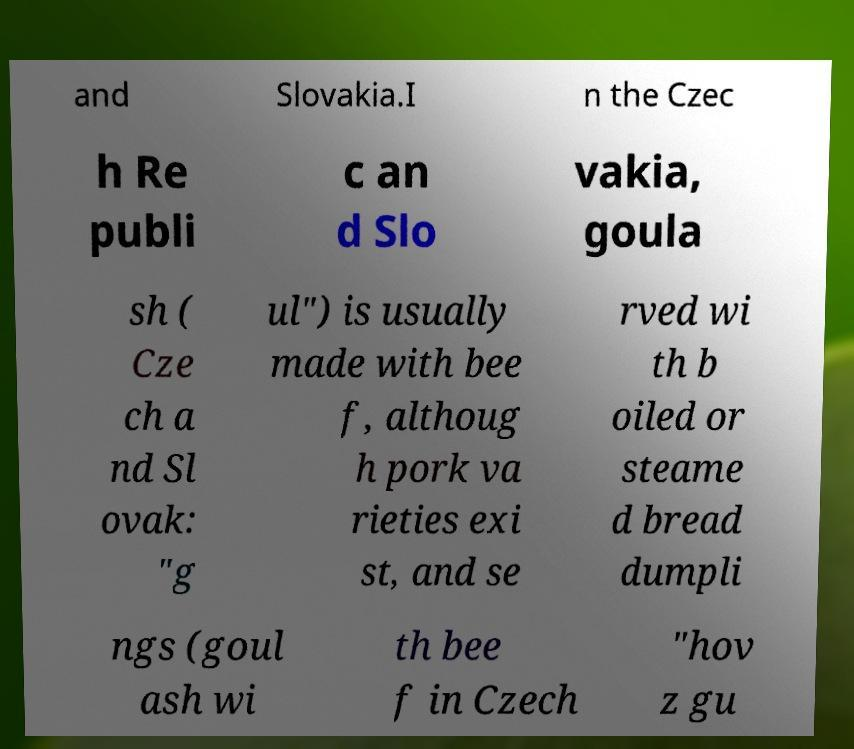Can you accurately transcribe the text from the provided image for me? and Slovakia.I n the Czec h Re publi c an d Slo vakia, goula sh ( Cze ch a nd Sl ovak: "g ul") is usually made with bee f, althoug h pork va rieties exi st, and se rved wi th b oiled or steame d bread dumpli ngs (goul ash wi th bee f in Czech "hov z gu 